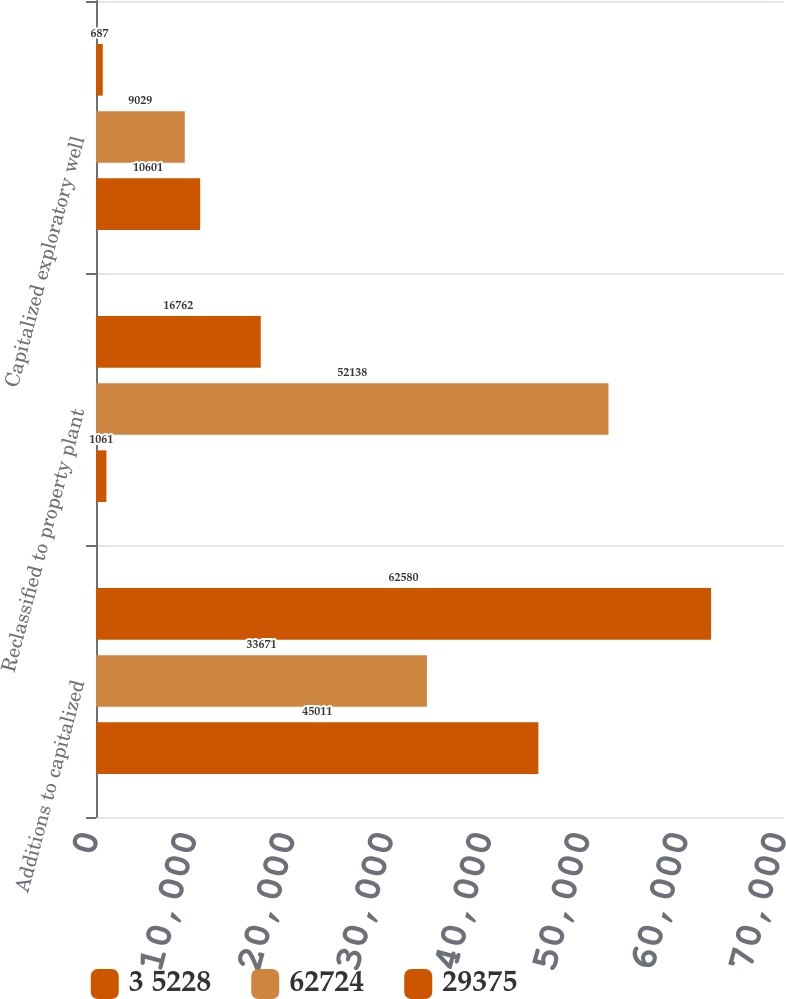Convert chart. <chart><loc_0><loc_0><loc_500><loc_500><stacked_bar_chart><ecel><fcel>Additions to capitalized<fcel>Reclassified to property plant<fcel>Capitalized exploratory well<nl><fcel>3 5228<fcel>62580<fcel>16762<fcel>687<nl><fcel>62724<fcel>33671<fcel>52138<fcel>9029<nl><fcel>29375<fcel>45011<fcel>1061<fcel>10601<nl></chart> 